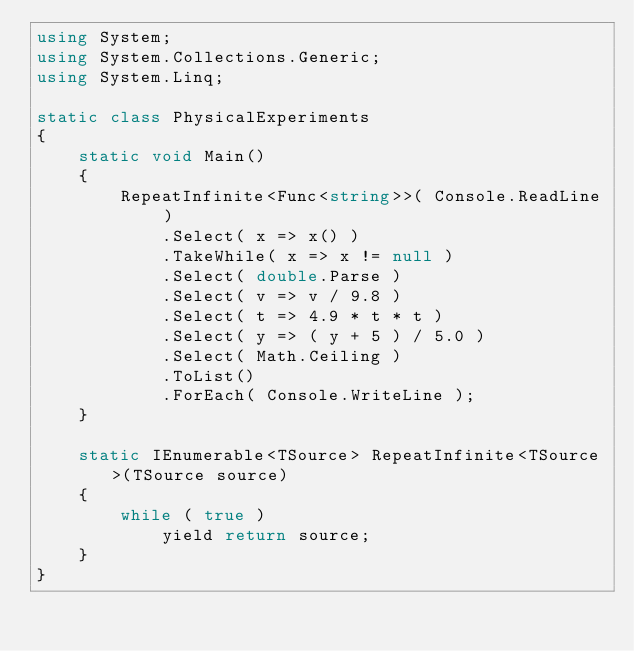Convert code to text. <code><loc_0><loc_0><loc_500><loc_500><_C#_>using System;
using System.Collections.Generic;
using System.Linq;

static class PhysicalExperiments
{
    static void Main()
    {
        RepeatInfinite<Func<string>>( Console.ReadLine )
            .Select( x => x() )
            .TakeWhile( x => x != null )
            .Select( double.Parse )
            .Select( v => v / 9.8 )
            .Select( t => 4.9 * t * t )
            .Select( y => ( y + 5 ) / 5.0 )
            .Select( Math.Ceiling )
            .ToList()
            .ForEach( Console.WriteLine );
    }

    static IEnumerable<TSource> RepeatInfinite<TSource>(TSource source)
    {
        while ( true )
            yield return source;
    }
}</code> 